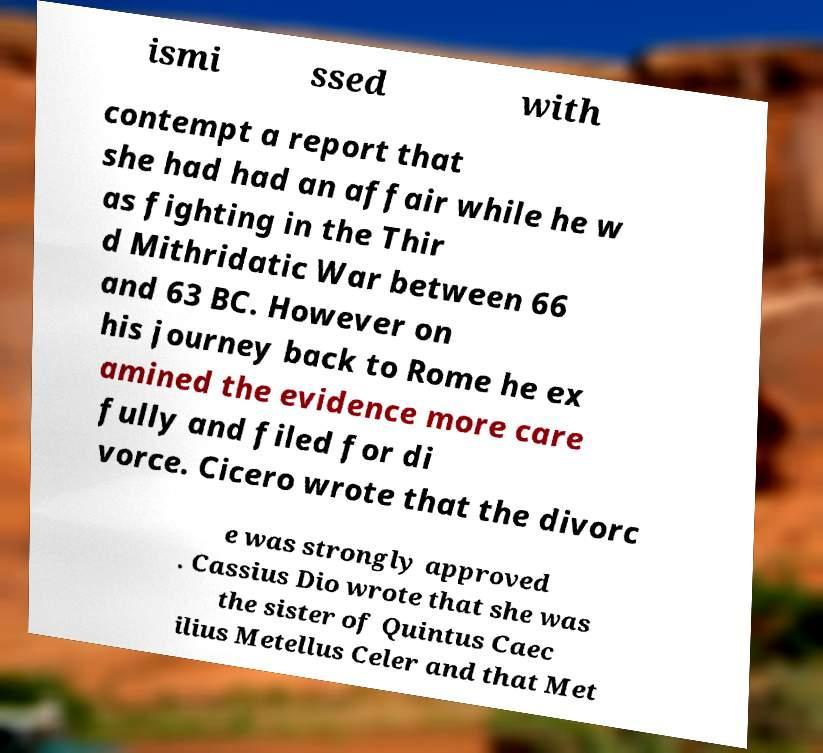There's text embedded in this image that I need extracted. Can you transcribe it verbatim? ismi ssed with contempt a report that she had had an affair while he w as fighting in the Thir d Mithridatic War between 66 and 63 BC. However on his journey back to Rome he ex amined the evidence more care fully and filed for di vorce. Cicero wrote that the divorc e was strongly approved . Cassius Dio wrote that she was the sister of Quintus Caec ilius Metellus Celer and that Met 